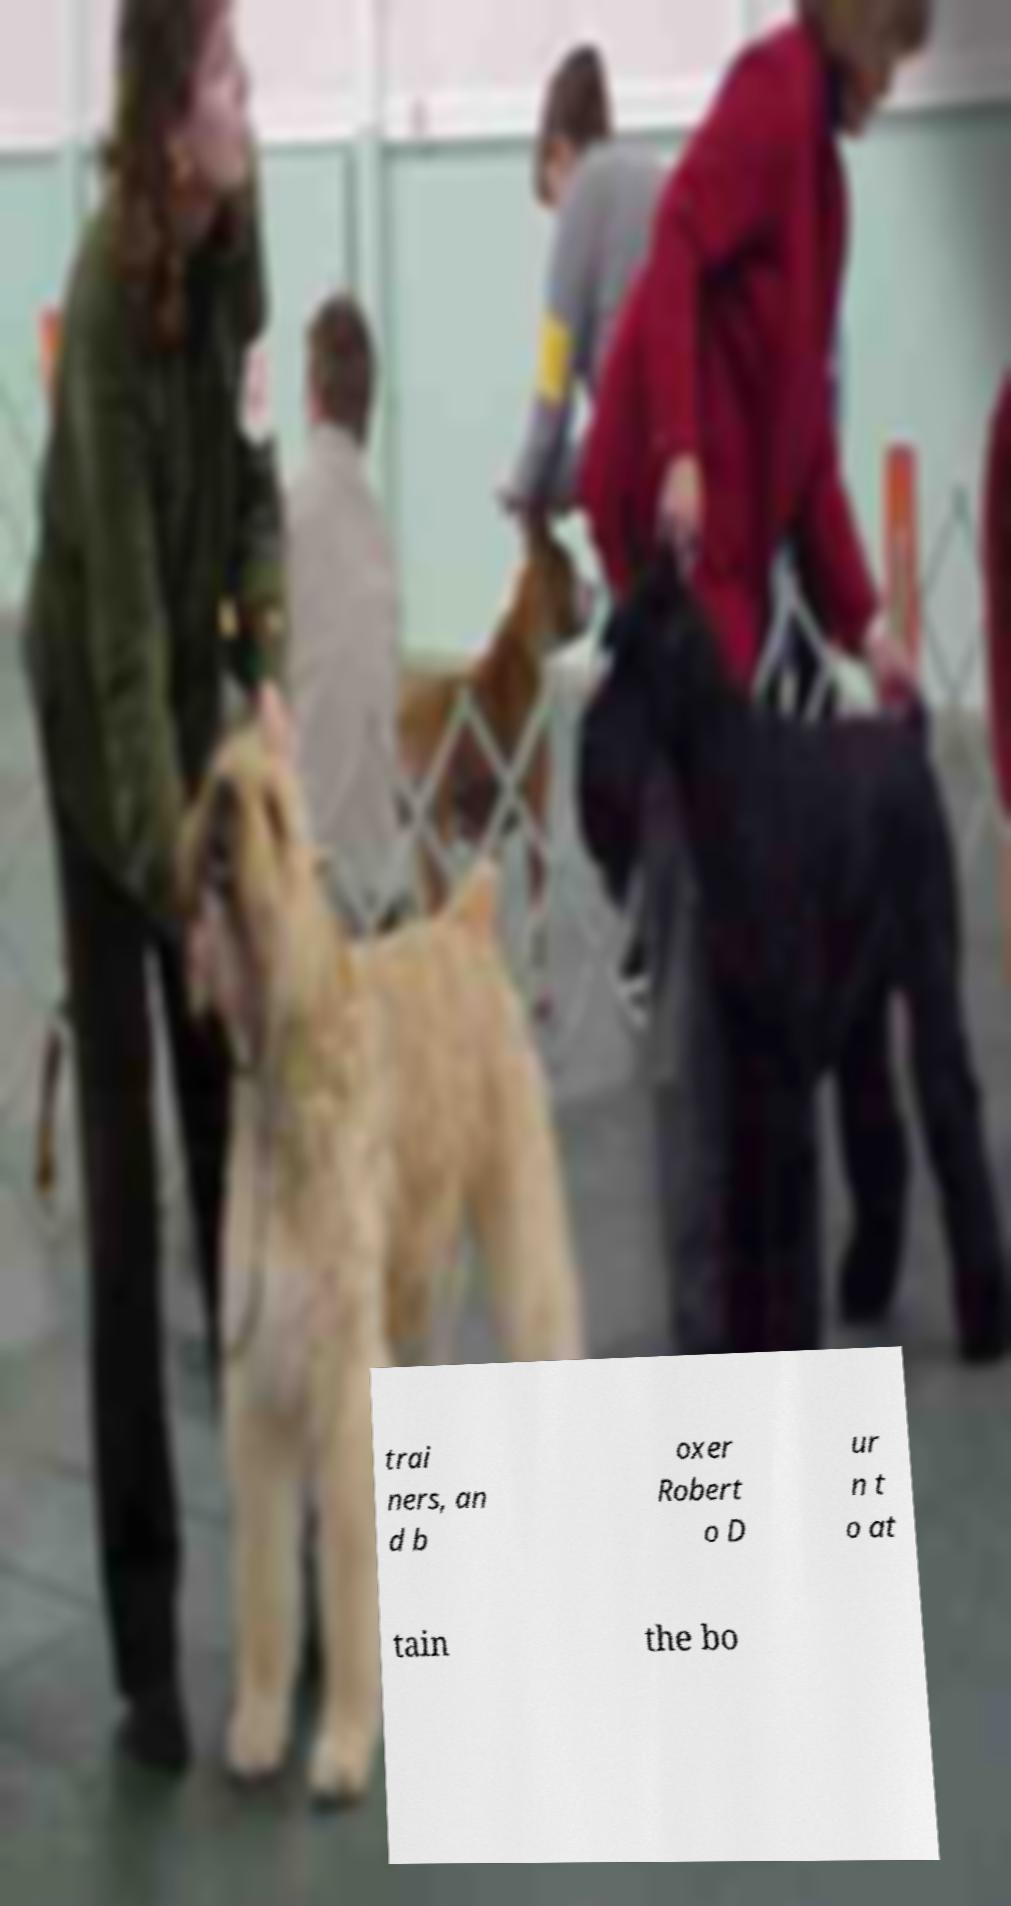For documentation purposes, I need the text within this image transcribed. Could you provide that? trai ners, an d b oxer Robert o D ur n t o at tain the bo 